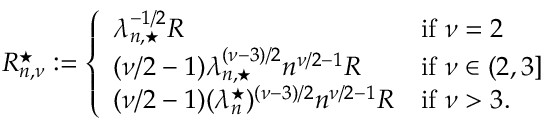Convert formula to latex. <formula><loc_0><loc_0><loc_500><loc_500>\begin{array} { r } { R _ { n , \nu } ^ { ^ { * } } \colon = \left \{ \begin{array} { l l } { \lambda _ { n , ^ { * } } ^ { - 1 / 2 } R } & { i f \nu = 2 } \\ { ( \nu / 2 - 1 ) \lambda _ { n , ^ { * } } ^ { ( \nu - 3 ) / 2 } n ^ { \nu / 2 - 1 } R } & { i f \nu \in ( 2 , 3 ] } \\ { ( \nu / 2 - 1 ) ( \lambda _ { n } ^ { ^ { * } } ) ^ { ( \nu - 3 ) / 2 } n ^ { \nu / 2 - 1 } R } & { i f \nu > 3 . } \end{array} } \end{array}</formula> 